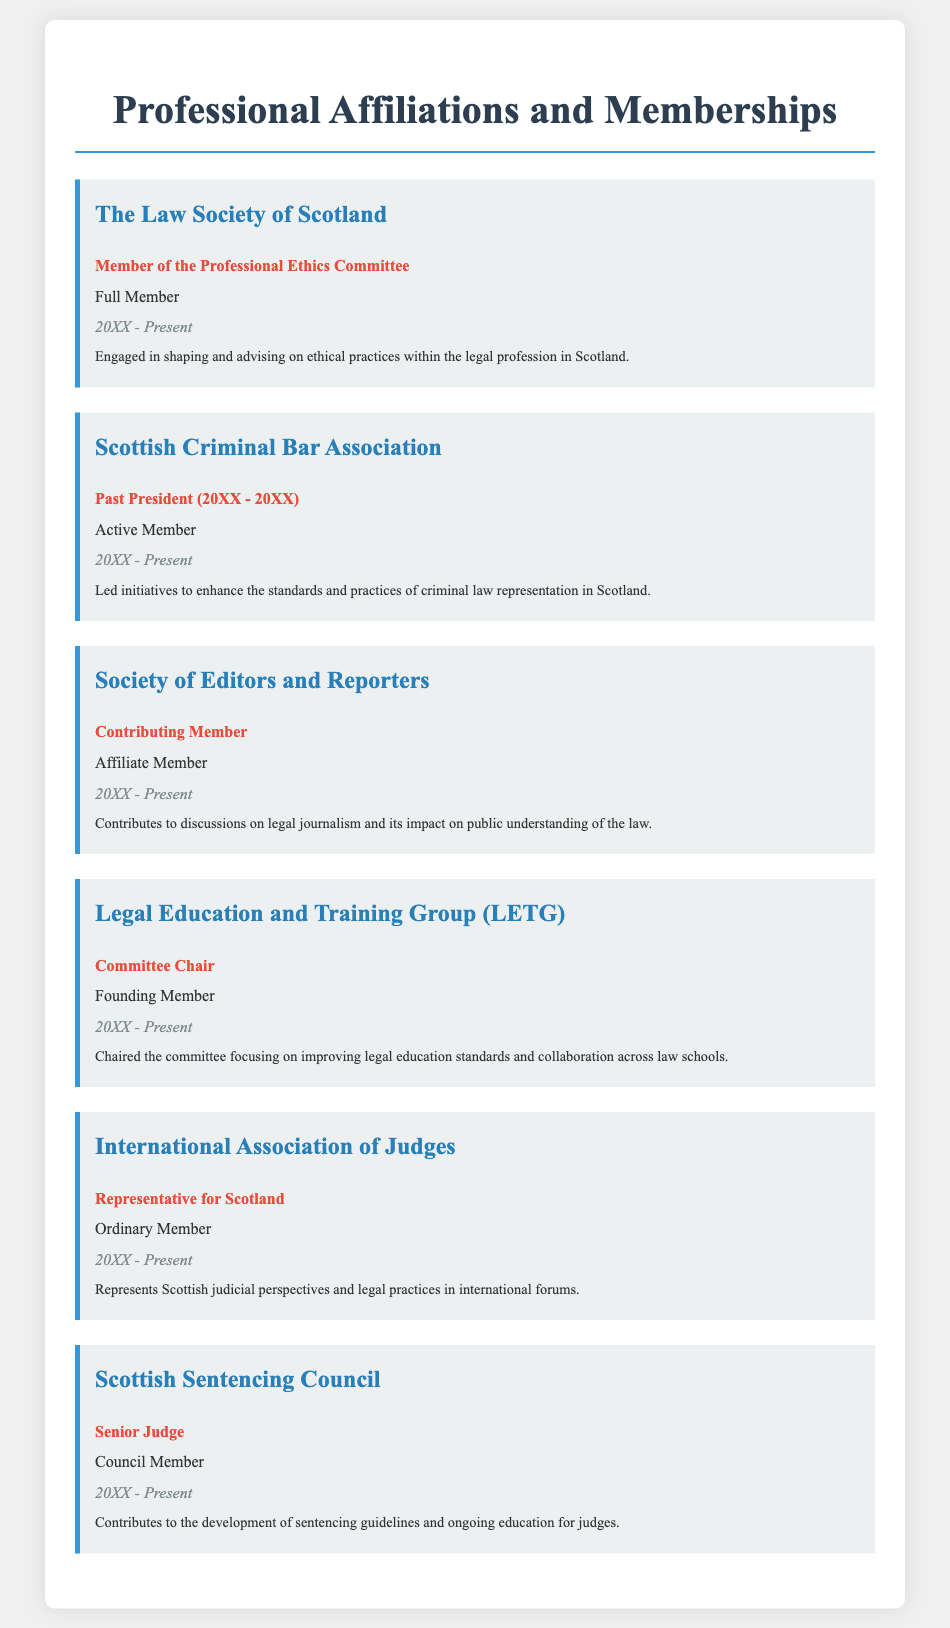What is the first organization listed? The first organization in the document is where the member engages in ethical practices within the legal profession.
Answer: The Law Society of Scotland What role does the individual hold in the Scottish Sentencing Council? The specific title and position held in the Scottish Sentencing Council is mentioned in the document.
Answer: Senior Judge What is the time span of involvement with the Scottish Criminal Bar Association? The document states the years of active membership for this organization.
Answer: 20XX - Present Who chairs the Legal Education and Training Group? The document identifies the individual responsible for leading the committee in the group.
Answer: Committee Chair In what capacity does the individual serve in the International Association of Judges? The document specifies the individual's official designation within this international organization.
Answer: Representative for Scotland Which organization focuses on legal journalism? The affiliated organization that addresses discussions on legal journalism is specified in the document.
Answer: Society of Editors and Reporters What was the previous leadership position held by the individual in the Scottish Criminal Bar Association? The document details the past leadership role in this particular organization before current engagements.
Answer: Past President How long has the individual been a member of the Professional Ethics Committee? The document indicates the duration of membership for this committee since its inception.
Answer: 20XX - Present What is the nature of membership in the Society of Editors and Reporters? The type of membership held in this organization is described in a specific manner in the document.
Answer: Affiliate Member 